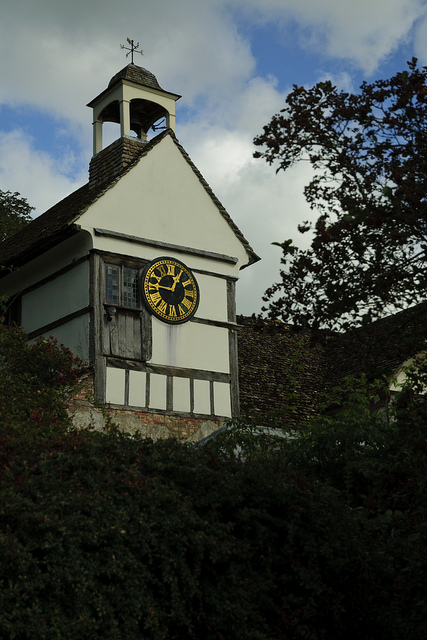<image>What time is showing on the clock? I am not sure about the exact time showing on the clock. It can be '1:45', '1245', '12:45', '1:30', or '12 46'. What time is showing on the clock? I don't know what time is showing on the clock. It can be both 1:45 and 12:45. 